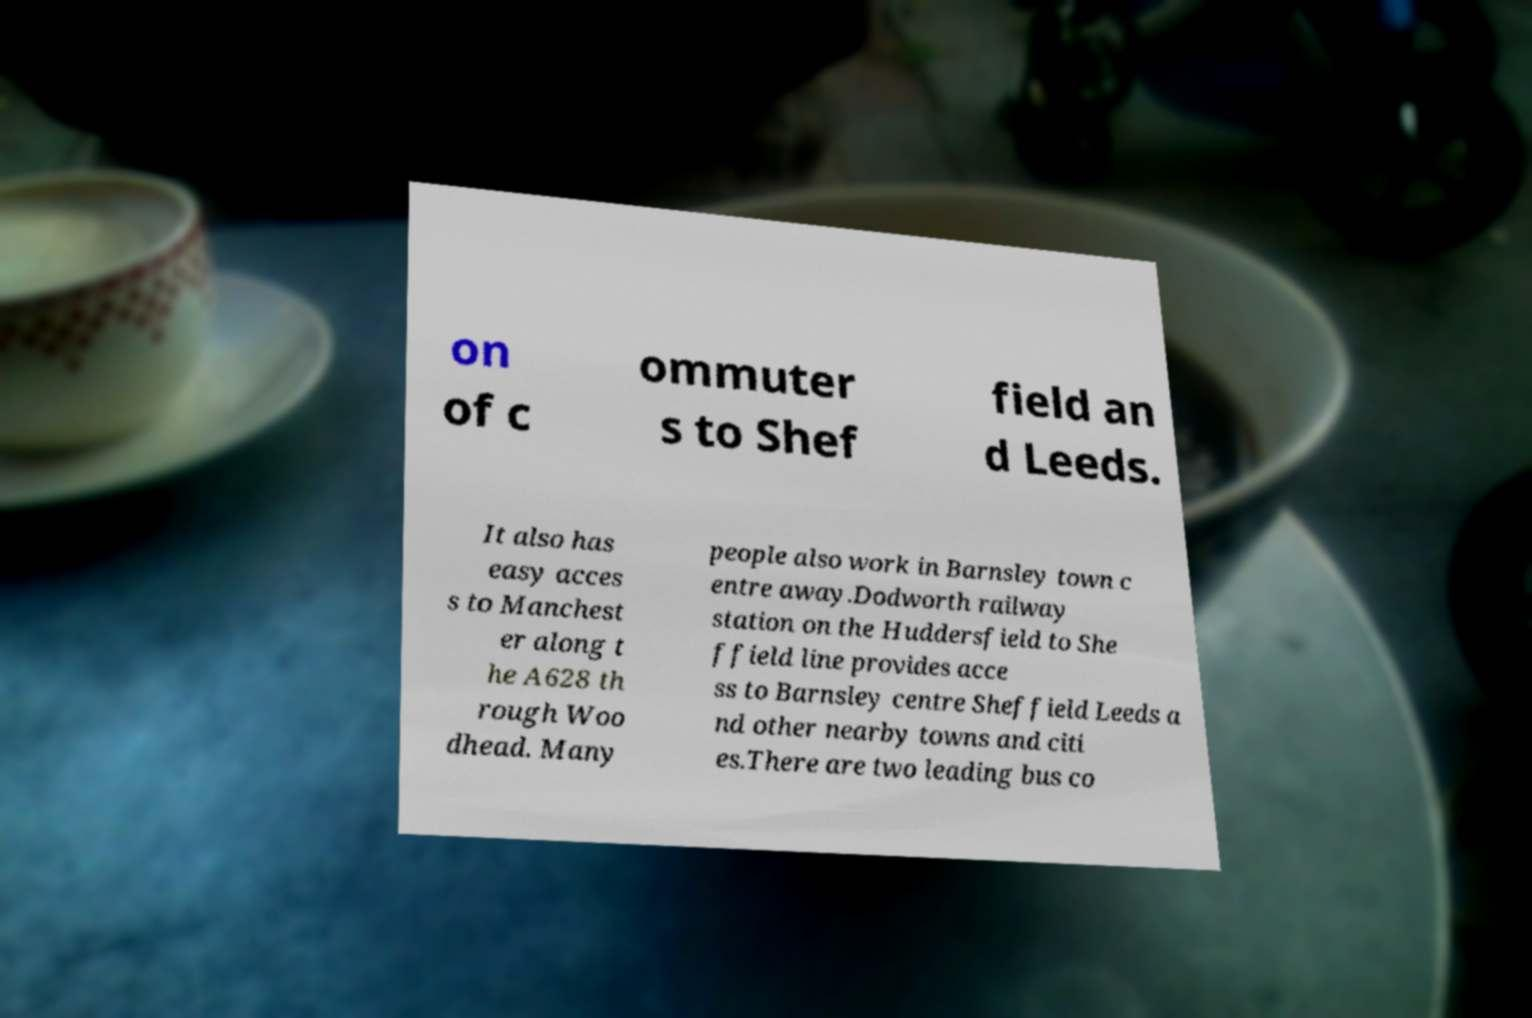What messages or text are displayed in this image? I need them in a readable, typed format. on of c ommuter s to Shef field an d Leeds. It also has easy acces s to Manchest er along t he A628 th rough Woo dhead. Many people also work in Barnsley town c entre away.Dodworth railway station on the Huddersfield to She ffield line provides acce ss to Barnsley centre Sheffield Leeds a nd other nearby towns and citi es.There are two leading bus co 